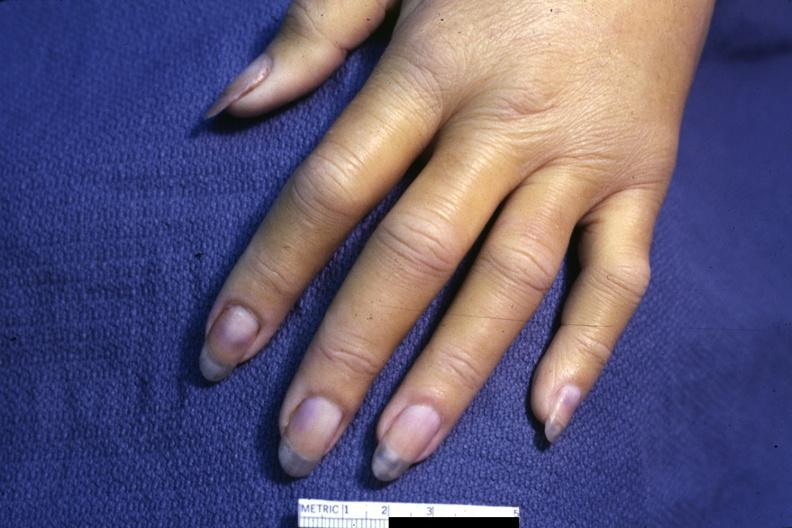does this image show case of dic not bad photo requires dark room to see subtle distal phalangeal cyanosis?
Answer the question using a single word or phrase. Yes 